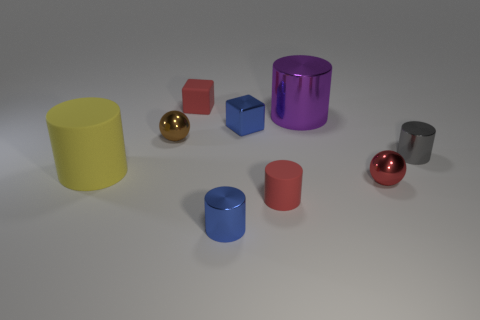There is a small blue object to the right of the small blue cylinder; is it the same shape as the small blue metal thing that is in front of the large yellow rubber object?
Your answer should be compact. No. Do the tiny brown thing and the blue cube have the same material?
Keep it short and to the point. Yes. There is a blue thing that is in front of the small blue object behind the red matte object that is in front of the brown shiny object; what is its size?
Your response must be concise. Small. What number of other things are there of the same color as the metal cube?
Ensure brevity in your answer.  1. The gray thing that is the same size as the metal block is what shape?
Make the answer very short. Cylinder. What number of big things are brown cylinders or red matte blocks?
Offer a very short reply. 0. Is there a rubber cylinder behind the small rubber object that is in front of the tiny red object that is to the right of the large purple cylinder?
Your answer should be very brief. Yes. Is there a yellow rubber block of the same size as the gray thing?
Provide a succinct answer. No. What is the material of the blue block that is the same size as the gray shiny cylinder?
Your answer should be very brief. Metal. There is a red cylinder; is its size the same as the ball that is on the right side of the small blue cylinder?
Ensure brevity in your answer.  Yes. 